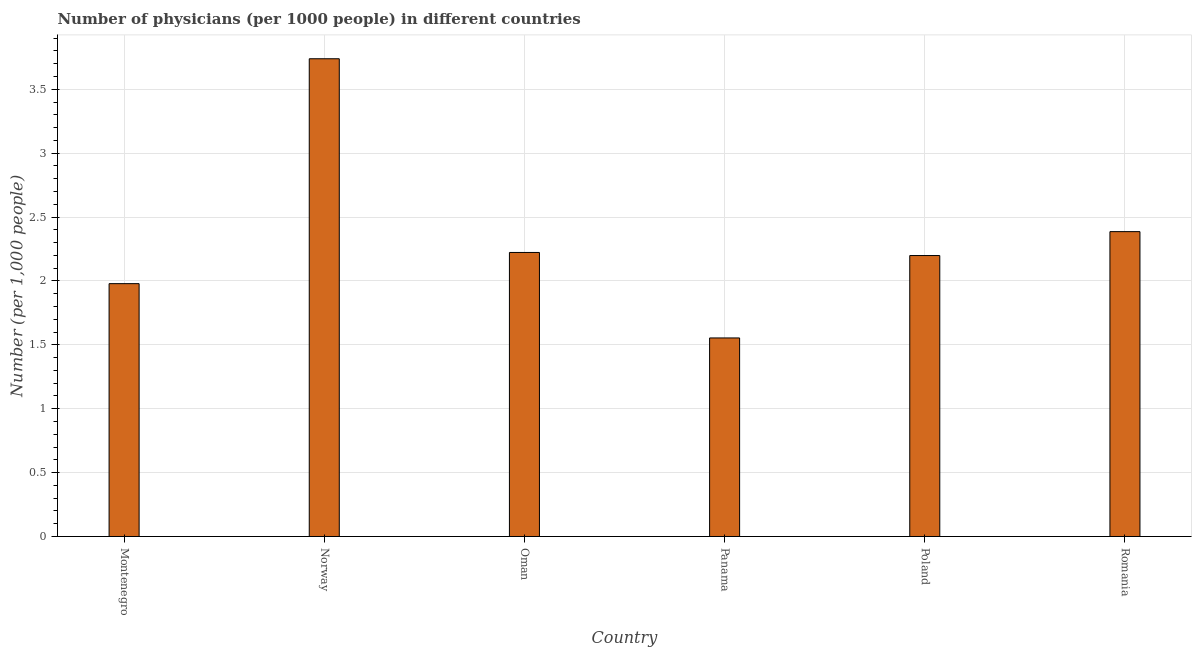Does the graph contain any zero values?
Provide a succinct answer. No. Does the graph contain grids?
Provide a short and direct response. Yes. What is the title of the graph?
Give a very brief answer. Number of physicians (per 1000 people) in different countries. What is the label or title of the X-axis?
Your answer should be very brief. Country. What is the label or title of the Y-axis?
Offer a terse response. Number (per 1,0 people). What is the number of physicians in Montenegro?
Your response must be concise. 1.98. Across all countries, what is the maximum number of physicians?
Your response must be concise. 3.74. Across all countries, what is the minimum number of physicians?
Your answer should be very brief. 1.55. In which country was the number of physicians maximum?
Your answer should be compact. Norway. In which country was the number of physicians minimum?
Your answer should be very brief. Panama. What is the sum of the number of physicians?
Your answer should be compact. 14.08. What is the difference between the number of physicians in Oman and Poland?
Your answer should be very brief. 0.02. What is the average number of physicians per country?
Offer a terse response. 2.35. What is the median number of physicians?
Your response must be concise. 2.21. In how many countries, is the number of physicians greater than 3.8 ?
Your answer should be compact. 0. What is the ratio of the number of physicians in Poland to that in Romania?
Ensure brevity in your answer.  0.92. Is the number of physicians in Norway less than that in Oman?
Make the answer very short. No. What is the difference between the highest and the second highest number of physicians?
Your response must be concise. 1.35. What is the difference between the highest and the lowest number of physicians?
Your answer should be compact. 2.18. In how many countries, is the number of physicians greater than the average number of physicians taken over all countries?
Provide a succinct answer. 2. How many bars are there?
Your answer should be compact. 6. Are the values on the major ticks of Y-axis written in scientific E-notation?
Make the answer very short. No. What is the Number (per 1,000 people) in Montenegro?
Make the answer very short. 1.98. What is the Number (per 1,000 people) in Norway?
Keep it short and to the point. 3.74. What is the Number (per 1,000 people) in Oman?
Offer a very short reply. 2.22. What is the Number (per 1,000 people) in Panama?
Your answer should be very brief. 1.55. What is the Number (per 1,000 people) in Poland?
Ensure brevity in your answer.  2.2. What is the Number (per 1,000 people) in Romania?
Your response must be concise. 2.39. What is the difference between the Number (per 1,000 people) in Montenegro and Norway?
Offer a very short reply. -1.76. What is the difference between the Number (per 1,000 people) in Montenegro and Oman?
Ensure brevity in your answer.  -0.24. What is the difference between the Number (per 1,000 people) in Montenegro and Panama?
Make the answer very short. 0.42. What is the difference between the Number (per 1,000 people) in Montenegro and Poland?
Make the answer very short. -0.22. What is the difference between the Number (per 1,000 people) in Montenegro and Romania?
Give a very brief answer. -0.41. What is the difference between the Number (per 1,000 people) in Norway and Oman?
Give a very brief answer. 1.52. What is the difference between the Number (per 1,000 people) in Norway and Panama?
Keep it short and to the point. 2.19. What is the difference between the Number (per 1,000 people) in Norway and Poland?
Offer a very short reply. 1.54. What is the difference between the Number (per 1,000 people) in Norway and Romania?
Your answer should be compact. 1.35. What is the difference between the Number (per 1,000 people) in Oman and Panama?
Keep it short and to the point. 0.67. What is the difference between the Number (per 1,000 people) in Oman and Poland?
Keep it short and to the point. 0.02. What is the difference between the Number (per 1,000 people) in Oman and Romania?
Ensure brevity in your answer.  -0.16. What is the difference between the Number (per 1,000 people) in Panama and Poland?
Your answer should be very brief. -0.65. What is the difference between the Number (per 1,000 people) in Panama and Romania?
Offer a terse response. -0.83. What is the difference between the Number (per 1,000 people) in Poland and Romania?
Provide a short and direct response. -0.19. What is the ratio of the Number (per 1,000 people) in Montenegro to that in Norway?
Your response must be concise. 0.53. What is the ratio of the Number (per 1,000 people) in Montenegro to that in Oman?
Your answer should be very brief. 0.89. What is the ratio of the Number (per 1,000 people) in Montenegro to that in Panama?
Make the answer very short. 1.27. What is the ratio of the Number (per 1,000 people) in Montenegro to that in Poland?
Provide a succinct answer. 0.9. What is the ratio of the Number (per 1,000 people) in Montenegro to that in Romania?
Your answer should be compact. 0.83. What is the ratio of the Number (per 1,000 people) in Norway to that in Oman?
Provide a short and direct response. 1.68. What is the ratio of the Number (per 1,000 people) in Norway to that in Panama?
Offer a very short reply. 2.41. What is the ratio of the Number (per 1,000 people) in Norway to that in Poland?
Keep it short and to the point. 1.7. What is the ratio of the Number (per 1,000 people) in Norway to that in Romania?
Give a very brief answer. 1.57. What is the ratio of the Number (per 1,000 people) in Oman to that in Panama?
Make the answer very short. 1.43. What is the ratio of the Number (per 1,000 people) in Oman to that in Poland?
Offer a terse response. 1.01. What is the ratio of the Number (per 1,000 people) in Oman to that in Romania?
Offer a terse response. 0.93. What is the ratio of the Number (per 1,000 people) in Panama to that in Poland?
Ensure brevity in your answer.  0.71. What is the ratio of the Number (per 1,000 people) in Panama to that in Romania?
Your answer should be compact. 0.65. What is the ratio of the Number (per 1,000 people) in Poland to that in Romania?
Your answer should be very brief. 0.92. 